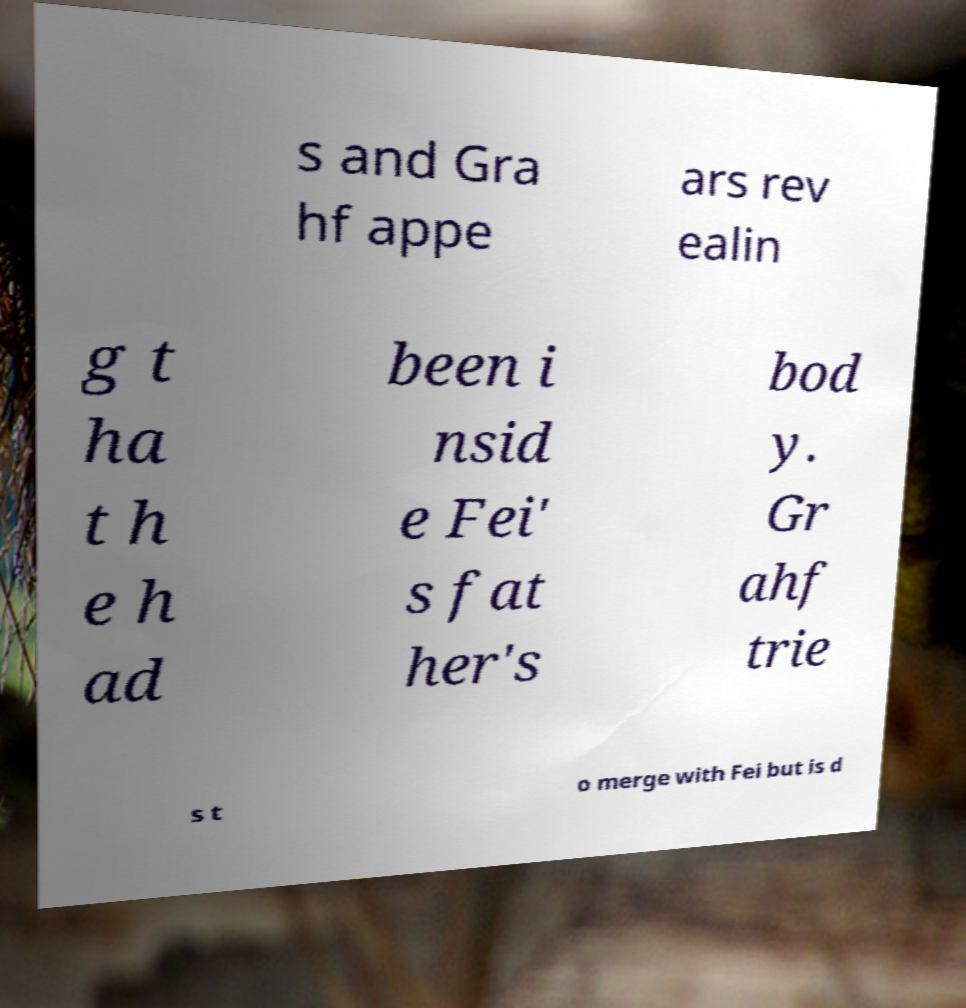I need the written content from this picture converted into text. Can you do that? s and Gra hf appe ars rev ealin g t ha t h e h ad been i nsid e Fei' s fat her's bod y. Gr ahf trie s t o merge with Fei but is d 